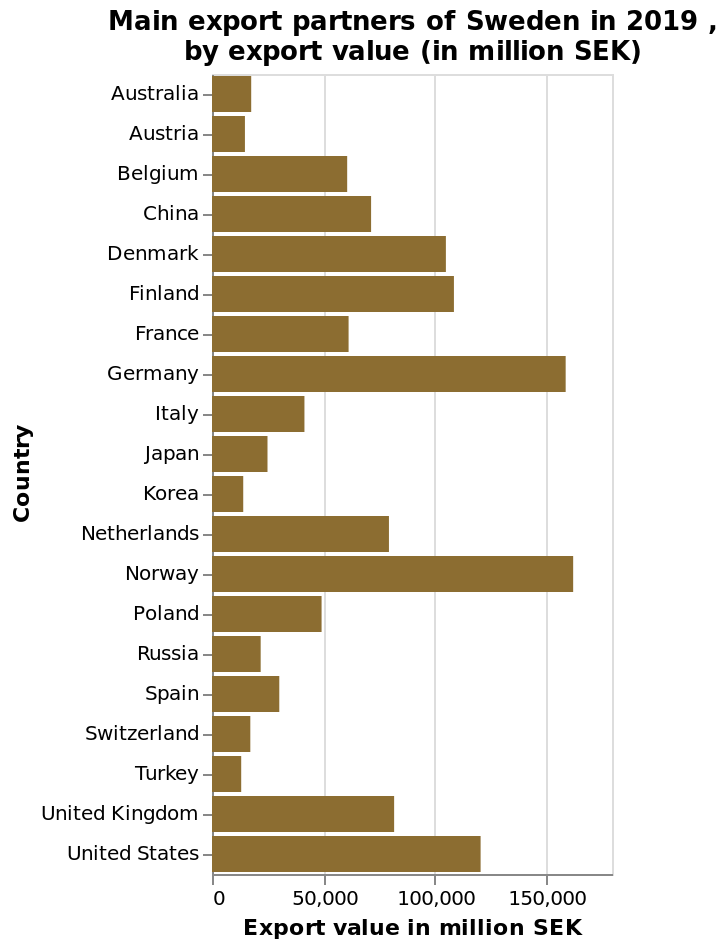<image>
Which countries had low export values to Sweden? Turkey, Korea, and Austria had very low export values to Sweden. 